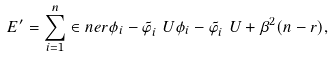<formula> <loc_0><loc_0><loc_500><loc_500>E ^ { \prime } = \sum _ { i = 1 } ^ { n } \in n e r { \phi _ { i } - \tilde { \varphi } _ { i } ^ { \ } U } { \phi _ { i } - \tilde { \varphi } _ { i } ^ { \ } U } + \beta ^ { 2 } ( n - r ) ,</formula> 